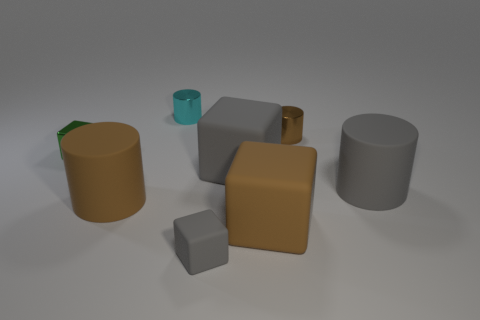How are the textures of the objects different? The textures vary among the objects; some have a smooth, glossy finish, while others exhibit a more matte or satin appearance. The contrasts in texture add depth and interest to the scene.  Which object looks the tallest, and can you describe its shape? The tallest object appears to be a cylinder with a brown surface. It has a height greater than its diameter, giving it a slender appearance. 